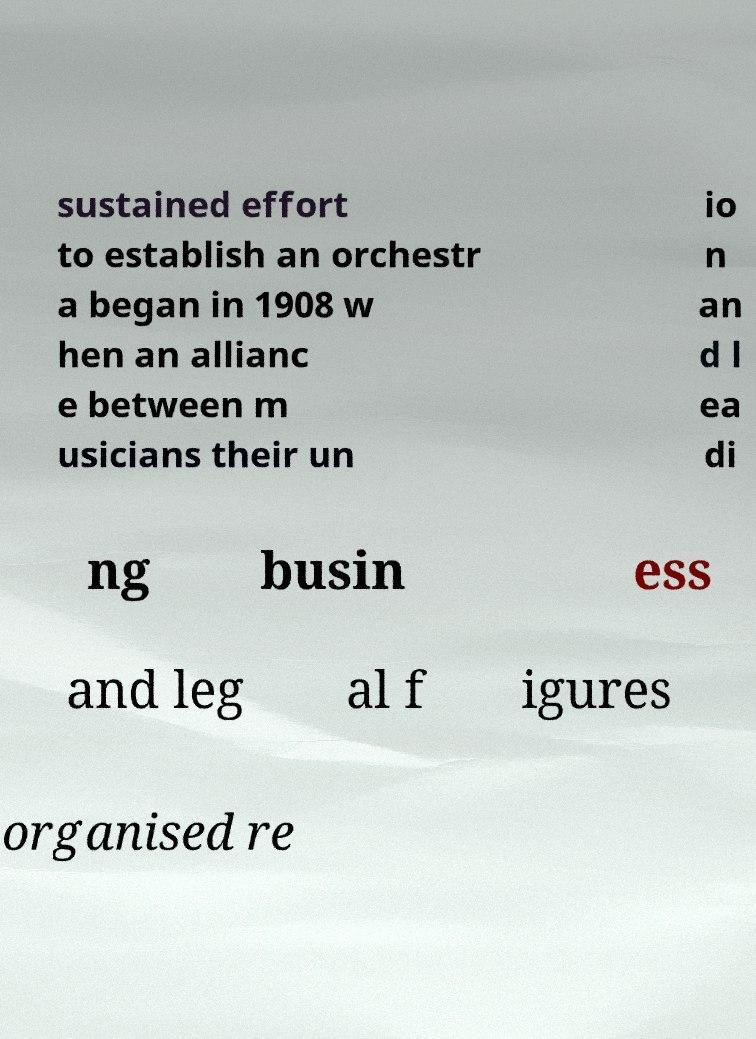Please identify and transcribe the text found in this image. sustained effort to establish an orchestr a began in 1908 w hen an allianc e between m usicians their un io n an d l ea di ng busin ess and leg al f igures organised re 